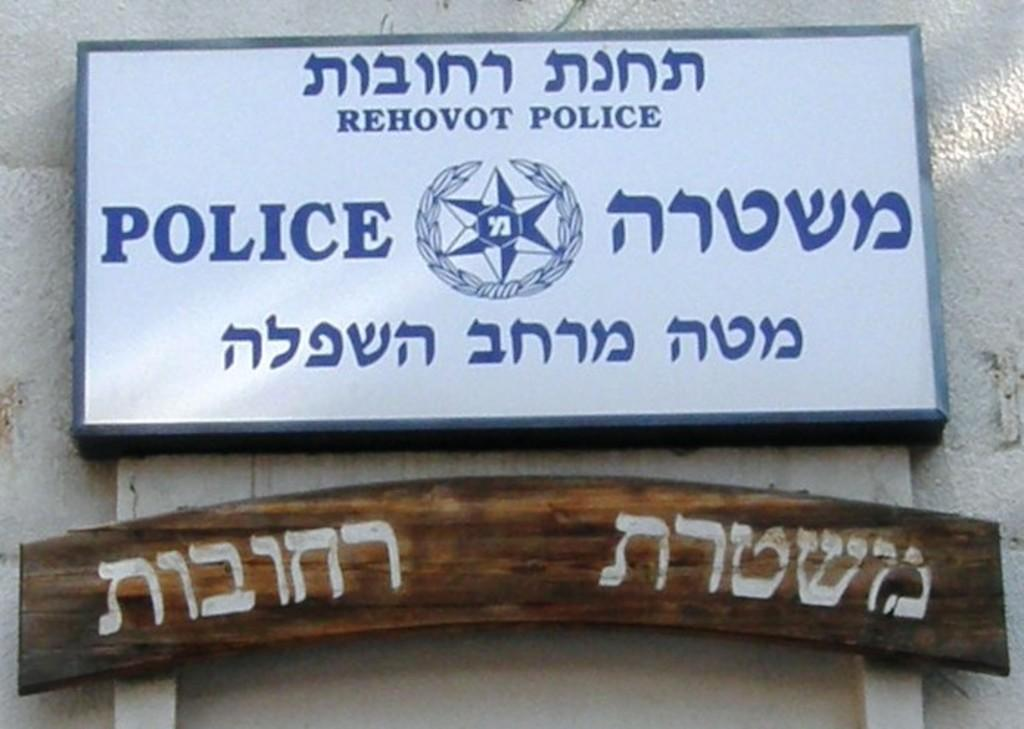<image>
Relay a brief, clear account of the picture shown. A sign for the Rehovot Police is in English and Arabic. 